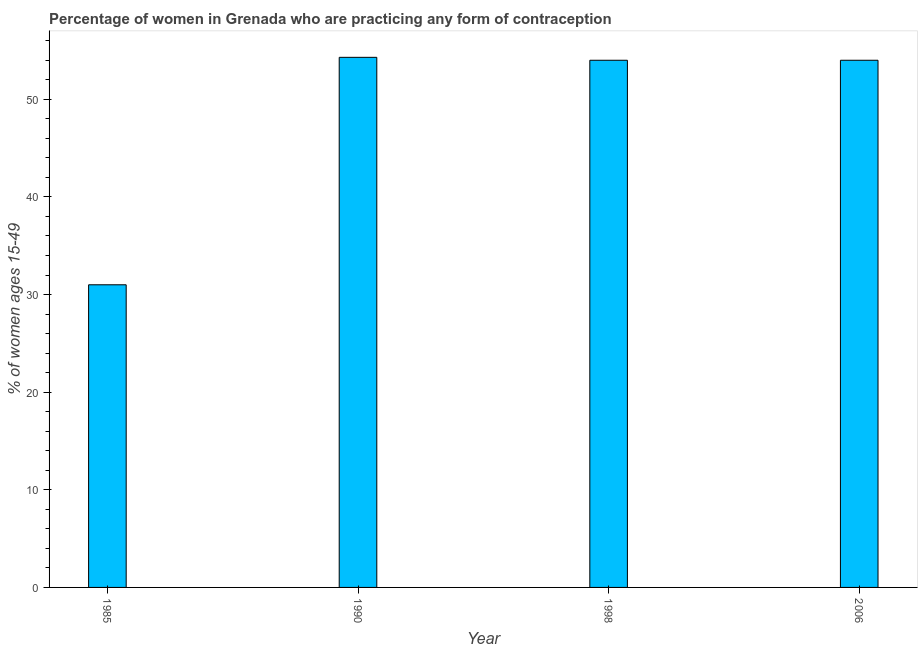Does the graph contain any zero values?
Provide a short and direct response. No. What is the title of the graph?
Make the answer very short. Percentage of women in Grenada who are practicing any form of contraception. What is the label or title of the Y-axis?
Your answer should be very brief. % of women ages 15-49. What is the contraceptive prevalence in 1985?
Provide a short and direct response. 31. Across all years, what is the maximum contraceptive prevalence?
Make the answer very short. 54.3. In which year was the contraceptive prevalence minimum?
Your answer should be very brief. 1985. What is the sum of the contraceptive prevalence?
Your answer should be very brief. 193.3. What is the average contraceptive prevalence per year?
Your answer should be compact. 48.33. What is the median contraceptive prevalence?
Make the answer very short. 54. What is the ratio of the contraceptive prevalence in 1985 to that in 2006?
Offer a very short reply. 0.57. Is the contraceptive prevalence in 1985 less than that in 1990?
Your response must be concise. Yes. What is the difference between the highest and the second highest contraceptive prevalence?
Your answer should be very brief. 0.3. Is the sum of the contraceptive prevalence in 1990 and 2006 greater than the maximum contraceptive prevalence across all years?
Ensure brevity in your answer.  Yes. What is the difference between the highest and the lowest contraceptive prevalence?
Provide a short and direct response. 23.3. In how many years, is the contraceptive prevalence greater than the average contraceptive prevalence taken over all years?
Give a very brief answer. 3. How many bars are there?
Ensure brevity in your answer.  4. Are all the bars in the graph horizontal?
Offer a terse response. No. How many years are there in the graph?
Keep it short and to the point. 4. What is the % of women ages 15-49 in 1985?
Make the answer very short. 31. What is the % of women ages 15-49 in 1990?
Ensure brevity in your answer.  54.3. What is the % of women ages 15-49 in 1998?
Make the answer very short. 54. What is the difference between the % of women ages 15-49 in 1985 and 1990?
Provide a short and direct response. -23.3. What is the difference between the % of women ages 15-49 in 1990 and 1998?
Keep it short and to the point. 0.3. What is the difference between the % of women ages 15-49 in 1998 and 2006?
Your response must be concise. 0. What is the ratio of the % of women ages 15-49 in 1985 to that in 1990?
Your answer should be very brief. 0.57. What is the ratio of the % of women ages 15-49 in 1985 to that in 1998?
Give a very brief answer. 0.57. What is the ratio of the % of women ages 15-49 in 1985 to that in 2006?
Make the answer very short. 0.57. What is the ratio of the % of women ages 15-49 in 1990 to that in 1998?
Offer a very short reply. 1.01. What is the ratio of the % of women ages 15-49 in 1998 to that in 2006?
Provide a succinct answer. 1. 